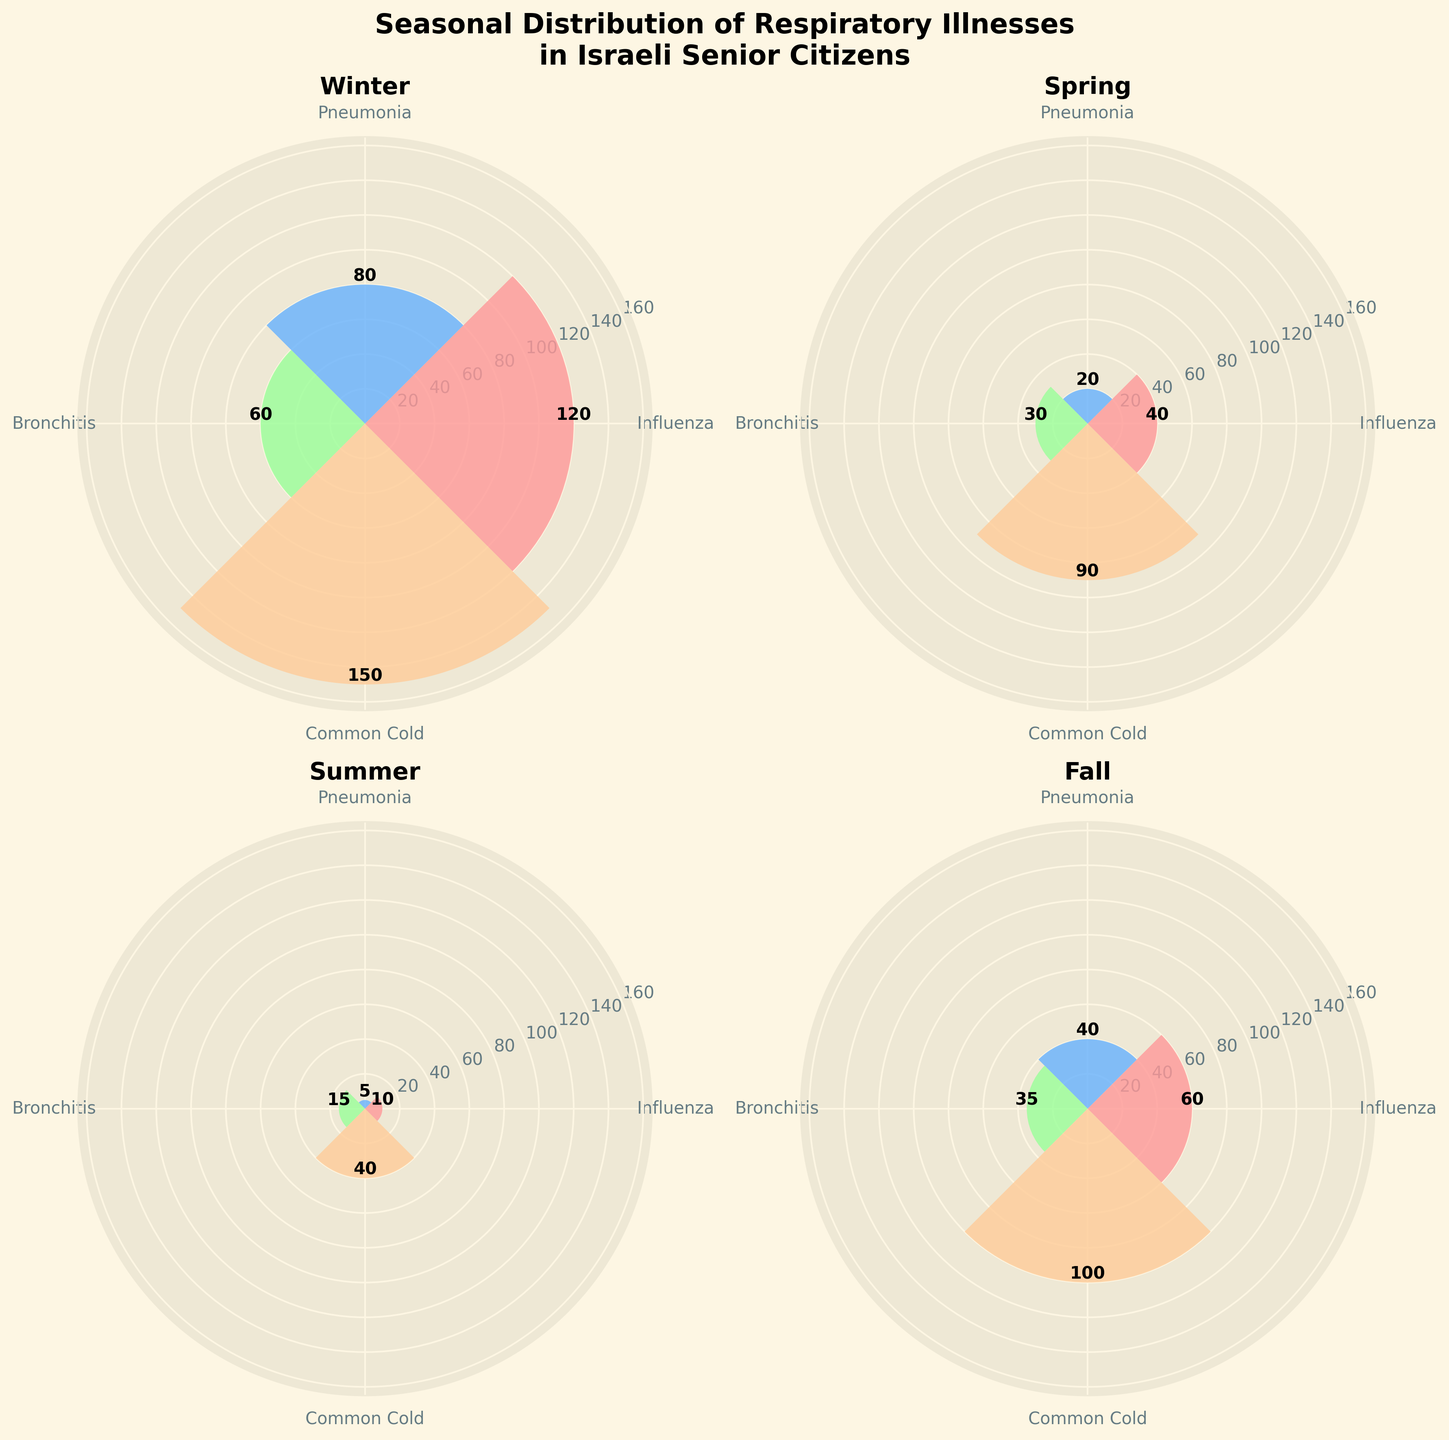What is the title of the figure? The title of the figure is found at the top and is set off from other text by its larger, bold font.
Answer: Seasonal Distribution of Respiratory Illnesses in Israeli Senior Citizens In which season is the incidence of Common Cold highest? By examining the segments labeled with "Common Cold" in each subplot, the highest bar can be seen in the "Winter" subplot.
Answer: Winter Which illness has the smallest count in Summer? By comparing the heights of the bars in the "Summer" subplot, the shortest one corresponds to "Pneumonia."
Answer: Pneumonia What is the total count of Influenza cases across all seasons? Sum the heights of the Influenza bars from each subplot (120 + 40 + 10 + 60) = 230.
Answer: 230 How does the count of Bronchitis cases in Winter compare to the count in Spring? The Winter subplot shows a Bronchitis bar of 60, while the Spring subplot shows 30. Thus, Winter has twice as many Bronchitis cases as Spring.
Answer: Winter has twice as many Which season shows the most even distribution across illnesses? By assessing the relative heights of bars within each subplot, Spring has bars that are more evenly balanced compared to other seasons.
Answer: Spring What is the difference in the count of Pneumonia cases between Winter and Fall? Subtract the height of the Pneumonia bar in Fall (40) from Winter (80), resulting in a difference of 40.
Answer: 40 Which illness shows a significant drop in cases from Winter to Summer? By comparing the bar heights for each illness between Winter and Summer, Influenza shows the most considerable drop (120 in Winter to 10 in Summer).
Answer: Influenza What is the average count of Common Cold cases over all four seasons? Calculate the mean by summing the Common Cold cases (150 + 90 + 40 + 100) and then dividing by 4, which results in (380/4) = 95.
Answer: 95 In which season are there the least total respiratory illness cases reported? Adding up the counts for each illness per season, Summer has the fewest cases: (10 + 5 + 15 + 40) = 70.
Answer: Summer 